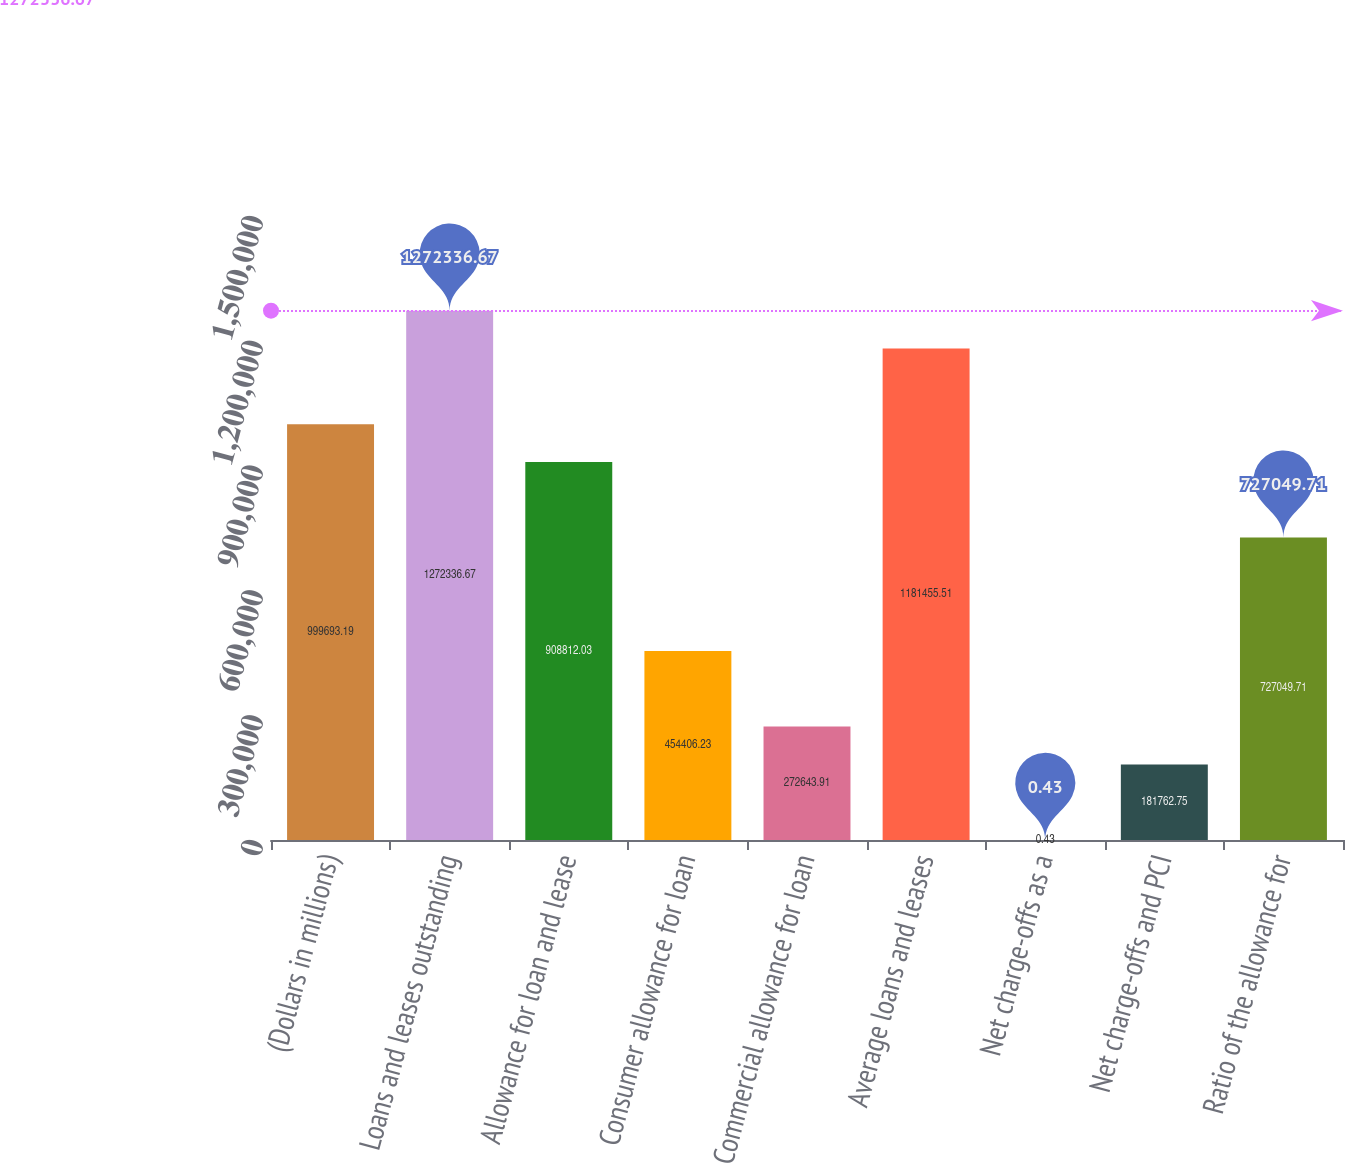Convert chart to OTSL. <chart><loc_0><loc_0><loc_500><loc_500><bar_chart><fcel>(Dollars in millions)<fcel>Loans and leases outstanding<fcel>Allowance for loan and lease<fcel>Consumer allowance for loan<fcel>Commercial allowance for loan<fcel>Average loans and leases<fcel>Net charge-offs as a<fcel>Net charge-offs and PCI<fcel>Ratio of the allowance for<nl><fcel>999693<fcel>1.27234e+06<fcel>908812<fcel>454406<fcel>272644<fcel>1.18146e+06<fcel>0.43<fcel>181763<fcel>727050<nl></chart> 